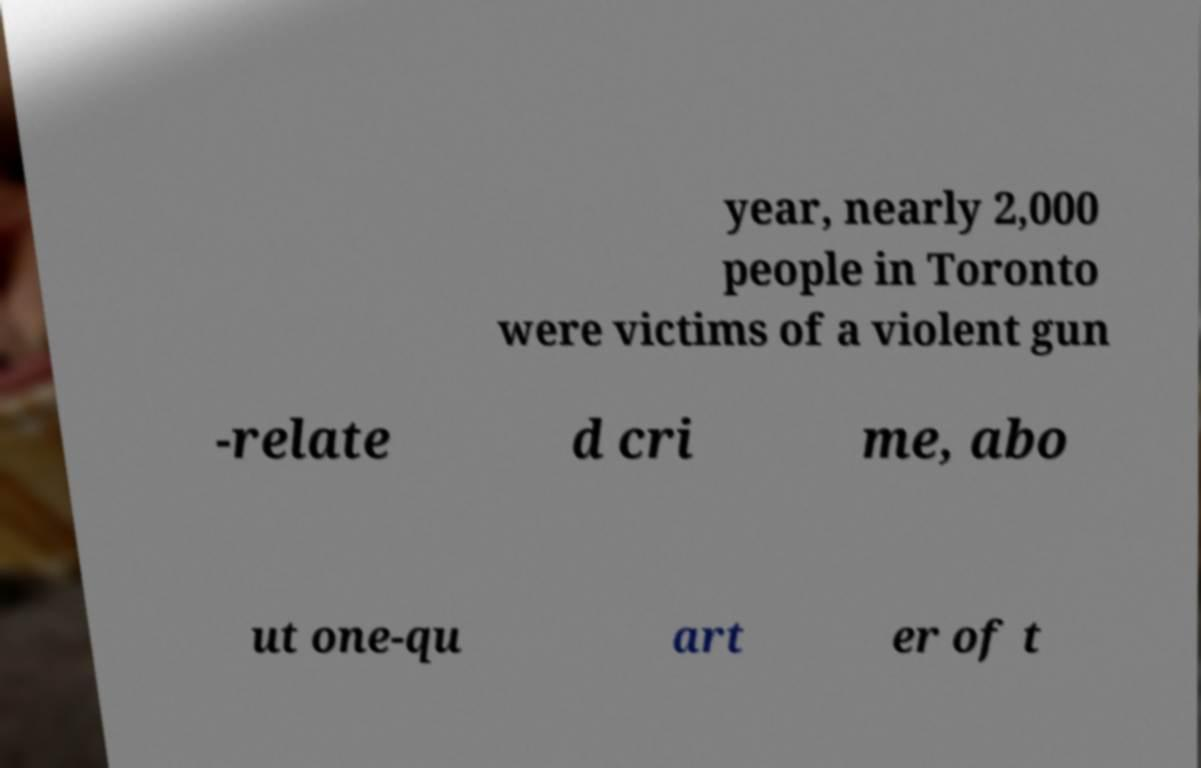Could you assist in decoding the text presented in this image and type it out clearly? year, nearly 2,000 people in Toronto were victims of a violent gun -relate d cri me, abo ut one-qu art er of t 